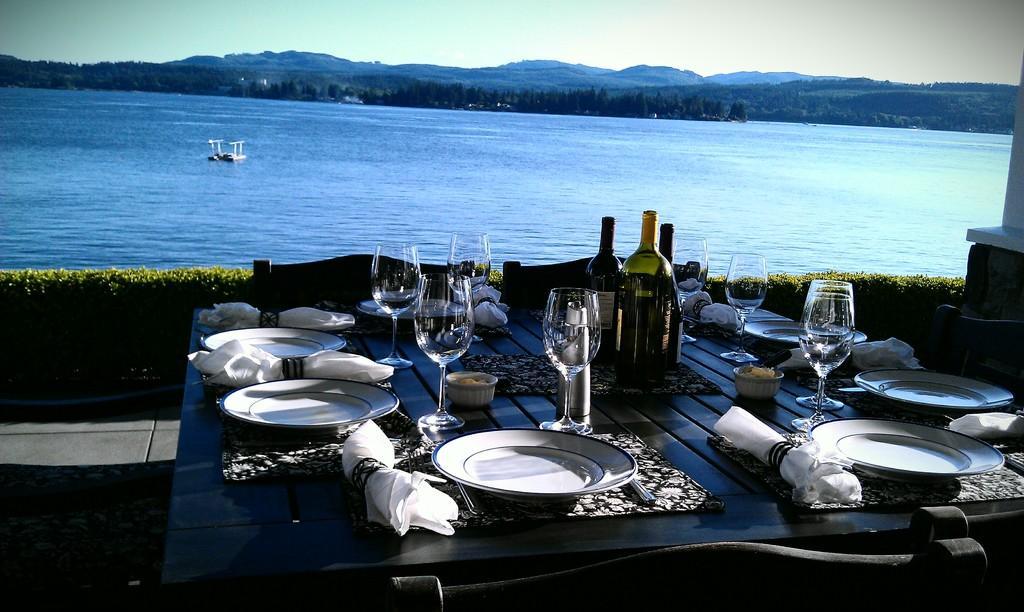Describe this image in one or two sentences. On the background of the picture we can see sky,hills. This is a sea. This is a boat. These are plants. these are chairs. In Front of a picture we can see table and on the table we can see plates, glasses, bottles, Clothes and spoons. 